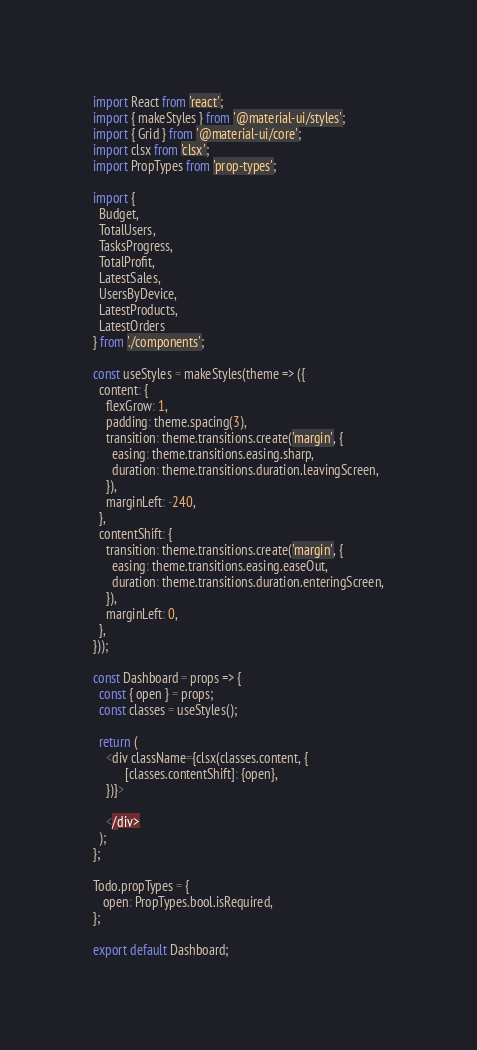<code> <loc_0><loc_0><loc_500><loc_500><_JavaScript_>import React from 'react';
import { makeStyles } from '@material-ui/styles';
import { Grid } from '@material-ui/core';
import clsx from 'clsx';
import PropTypes from 'prop-types';

import {
  Budget,
  TotalUsers,
  TasksProgress,
  TotalProfit,
  LatestSales,
  UsersByDevice,
  LatestProducts,
  LatestOrders
} from './components';

const useStyles = makeStyles(theme => ({
  content: {
    flexGrow: 1,
    padding: theme.spacing(3),
    transition: theme.transitions.create('margin', {
      easing: theme.transitions.easing.sharp,
      duration: theme.transitions.duration.leavingScreen,
    }),
    marginLeft: -240,
  },
  contentShift: {
    transition: theme.transitions.create('margin', {
      easing: theme.transitions.easing.easeOut,
      duration: theme.transitions.duration.enteringScreen,
    }),
    marginLeft: 0,
  },
}));

const Dashboard = props => {
  const { open } = props;
  const classes = useStyles();

  return (
    <div className={clsx(classes.content, {
          [classes.contentShift]: {open},
    })}>
      
    </div>
  );
};

Todo.propTypes = {
   open: PropTypes.bool.isRequired,
};

export default Dashboard;
</code> 